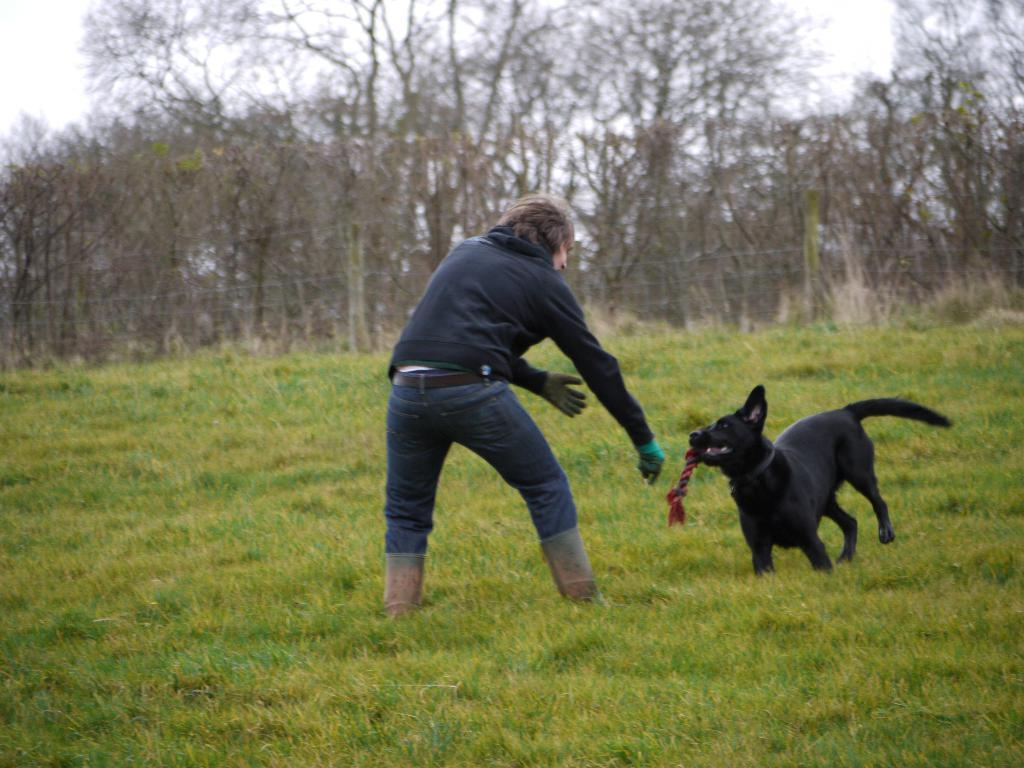Who is present in the image? There is a man in the image. What is the man doing in the image? The man is playing with a black dog in the image. Where are the man and dog located? The man and dog are in grass in the image. What can be seen in the background of the image? There are trees in the image. What type of industry is depicted in the image? There is no industry depicted in the image; it features a man playing with a black dog in grass with trees in the background. What nation is represented by the flag in the image? There is no flag present in the image. 